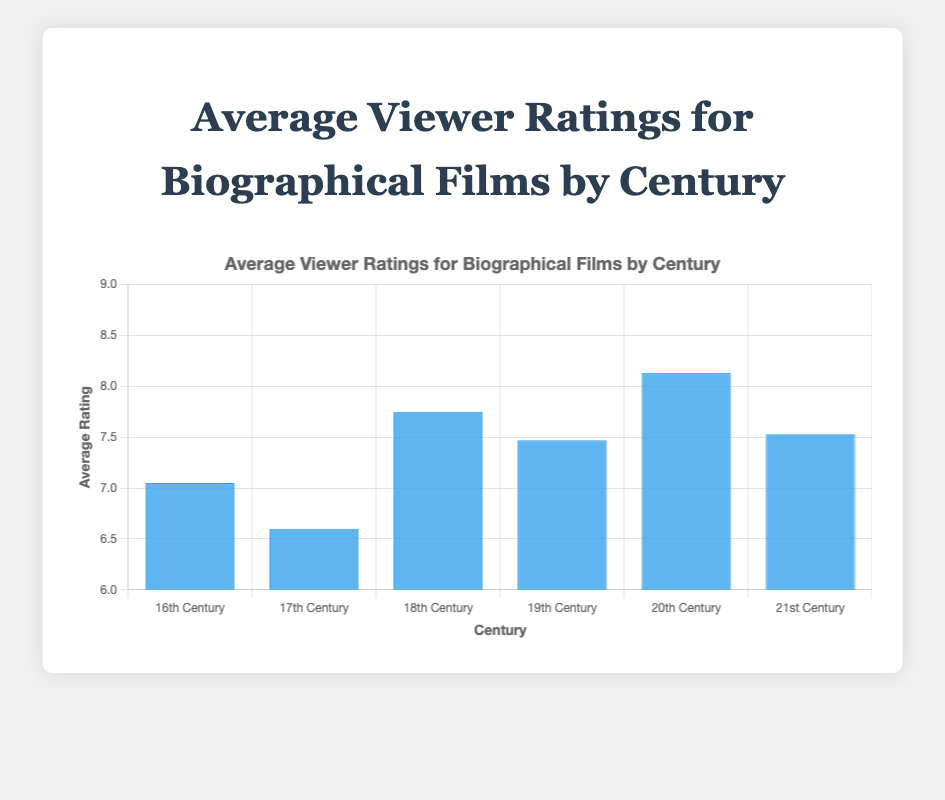What century has the highest average viewer rating for biographical films? The figure shows average viewer ratings for each century. The bar representing the 20th century is the tallest, indicating the highest average rating.
Answer: 20th Century What is the difference in average ratings between films depicting the 16th century and the 17th century? The average rating for 16th-century films is 7.05, and for 17th-century films, it is 6.6. The difference is calculated as 7.05 - 6.6 = 0.45.
Answer: 0.45 Which century has the lowest average viewer rating for biographical films? By inspecting the height of the bars in the figure, the 17th century has the shortest bar, indicating the lowest average rating.
Answer: 17th Century How many centuries have an average viewer rating higher than 7.0? By checking the bars taller than the 7.0 mark, there are four centuries: 16th, 18th, 19th, and 20th centuries.
Answer: 4 What is the average viewer rating for films depicting the 21st century? From the figure, the bar representing the 21st century shows an average rating of 7.53.
Answer: 7.53 By how much does the average viewer rating for 20th-century films exceed the average viewer rating for 18th-century films? The average rating for the 20th century is 8.13, and for the 18th century, it is 7.75. The difference is calculated as 8.13 - 7.75 = 0.38.
Answer: 0.38 What is the total average rating if you sum up the average viewer ratings for all centuries shown? Sum up each average rating: 7.05 (16th) + 6.6 (17th) + 7.75 (18th) + 7.47 (19th) + 8.13 (20th) + 7.53 (21st) = 44.53.
Answer: 44.53 Which century's films have an average rating closest to 7.5? The 21st century has an average rating of 7.53, which is closest to 7.5.
Answer: 21st Century How many centuries have an average viewer rating below 7.5? By inspecting the bars, three centuries (16th, 17th, 19th) have ratings below 7.5.
Answer: 3 